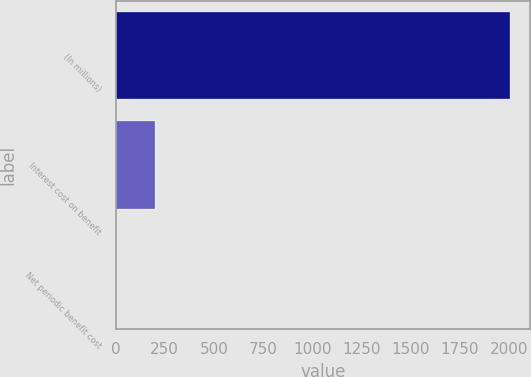<chart> <loc_0><loc_0><loc_500><loc_500><bar_chart><fcel>(In millions)<fcel>Interest cost on benefit<fcel>Net periodic benefit cost<nl><fcel>2007<fcel>202.23<fcel>1.7<nl></chart> 